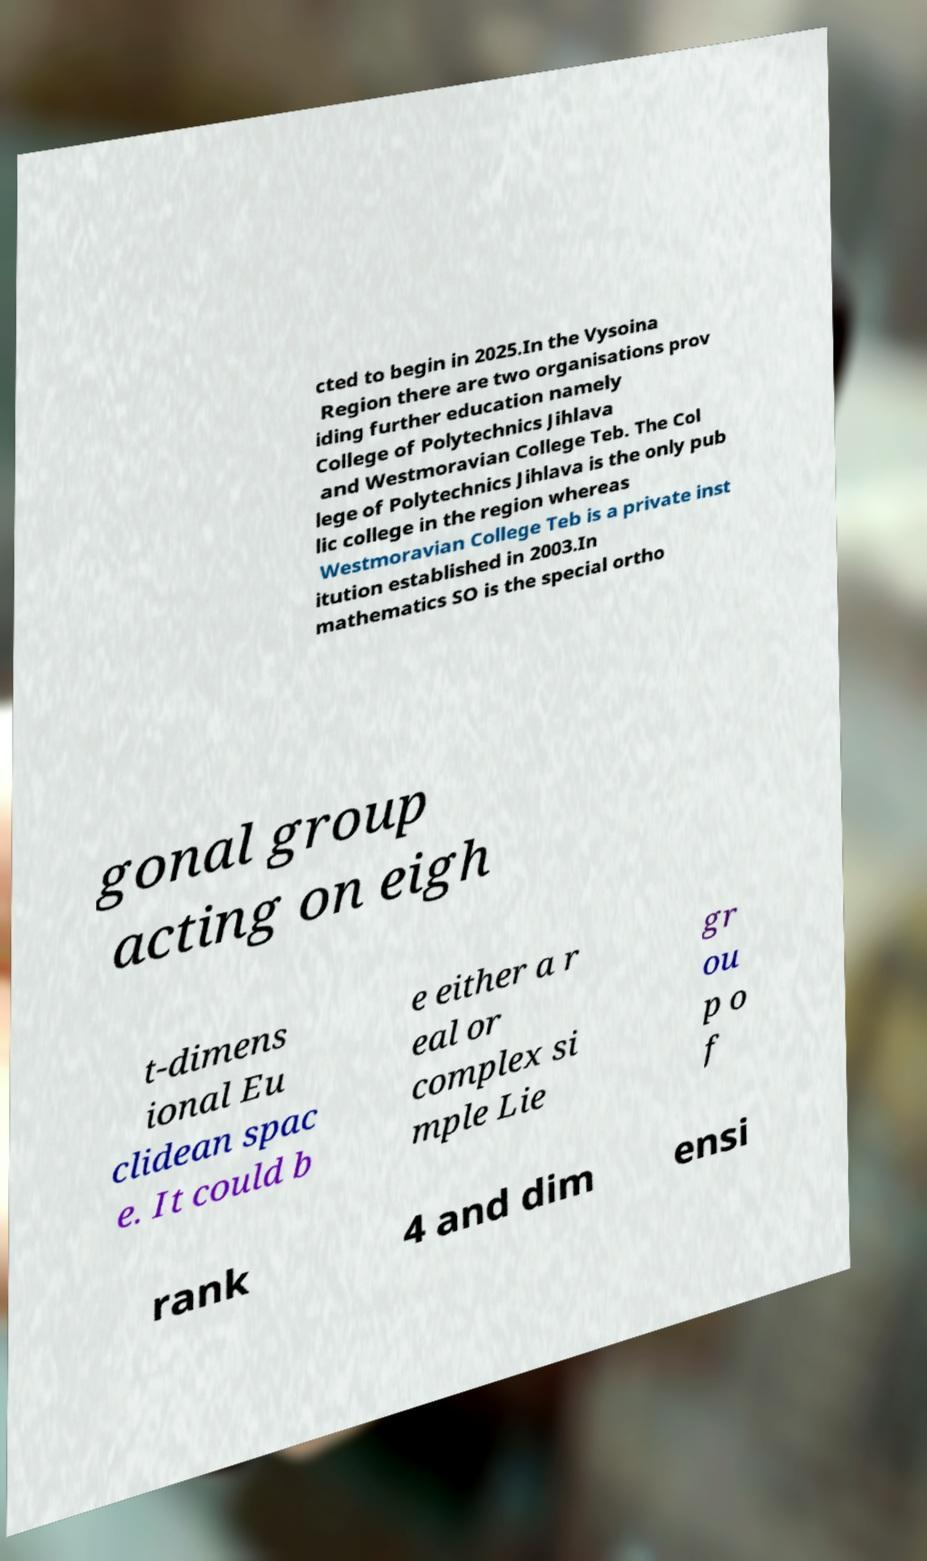Can you read and provide the text displayed in the image?This photo seems to have some interesting text. Can you extract and type it out for me? cted to begin in 2025.In the Vysoina Region there are two organisations prov iding further education namely College of Polytechnics Jihlava and Westmoravian College Teb. The Col lege of Polytechnics Jihlava is the only pub lic college in the region whereas Westmoravian College Teb is a private inst itution established in 2003.In mathematics SO is the special ortho gonal group acting on eigh t-dimens ional Eu clidean spac e. It could b e either a r eal or complex si mple Lie gr ou p o f rank 4 and dim ensi 